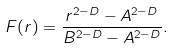<formula> <loc_0><loc_0><loc_500><loc_500>F ( r ) = \frac { r ^ { 2 - D } - A ^ { 2 - D } } { B ^ { 2 - D } - A ^ { 2 - D } } .</formula> 